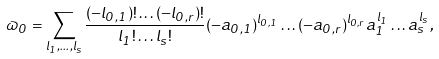<formula> <loc_0><loc_0><loc_500><loc_500>\varpi _ { 0 } = \sum _ { l _ { 1 } , \dots , l _ { s } } \frac { ( - l _ { 0 , 1 } ) ! \dots ( - l _ { 0 , r } ) ! } { l _ { 1 } ! \dots l _ { s } ! } ( - a _ { 0 , 1 } ) ^ { l _ { 0 , 1 } } \dots ( - a _ { 0 , r } ) ^ { l _ { 0 , r } } a _ { 1 } ^ { l _ { 1 } } \dots a _ { s } ^ { l _ { s } } ,</formula> 